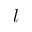Convert formula to latex. <formula><loc_0><loc_0><loc_500><loc_500>l</formula> 